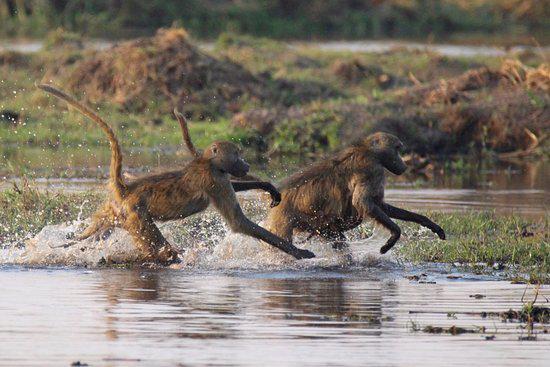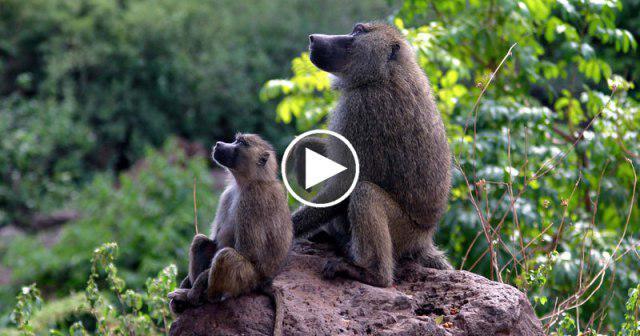The first image is the image on the left, the second image is the image on the right. Examine the images to the left and right. Is the description "One image shows baboons in the water creating splashes, and at least one of those monkeys has its tail raised." accurate? Answer yes or no. Yes. The first image is the image on the left, the second image is the image on the right. For the images shown, is this caption "An image contains exactly one primate." true? Answer yes or no. No. 